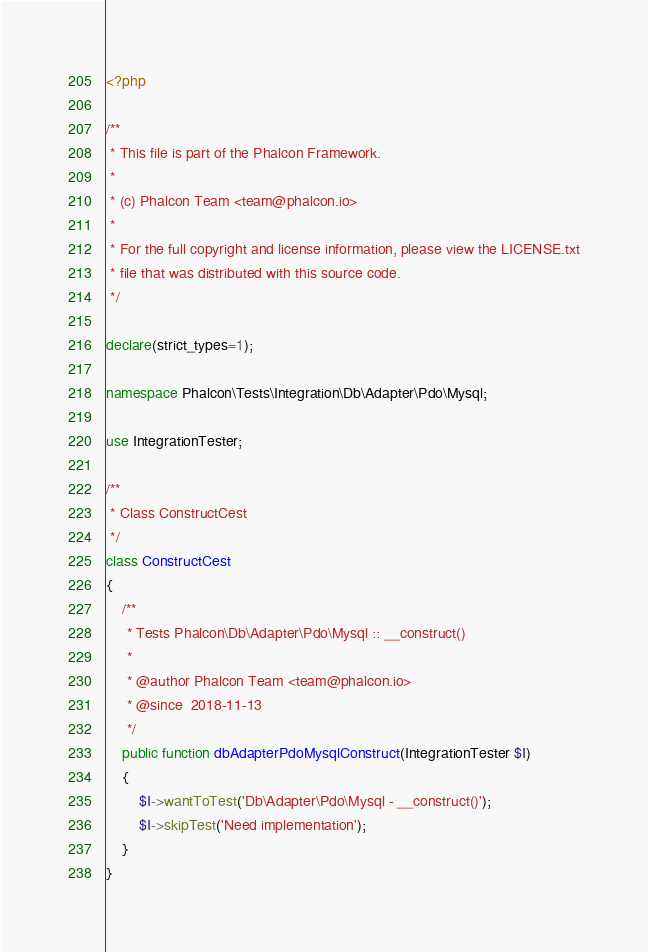<code> <loc_0><loc_0><loc_500><loc_500><_PHP_><?php

/**
 * This file is part of the Phalcon Framework.
 *
 * (c) Phalcon Team <team@phalcon.io>
 *
 * For the full copyright and license information, please view the LICENSE.txt
 * file that was distributed with this source code.
 */

declare(strict_types=1);

namespace Phalcon\Tests\Integration\Db\Adapter\Pdo\Mysql;

use IntegrationTester;

/**
 * Class ConstructCest
 */
class ConstructCest
{
    /**
     * Tests Phalcon\Db\Adapter\Pdo\Mysql :: __construct()
     *
     * @author Phalcon Team <team@phalcon.io>
     * @since  2018-11-13
     */
    public function dbAdapterPdoMysqlConstruct(IntegrationTester $I)
    {
        $I->wantToTest('Db\Adapter\Pdo\Mysql - __construct()');
        $I->skipTest('Need implementation');
    }
}
</code> 